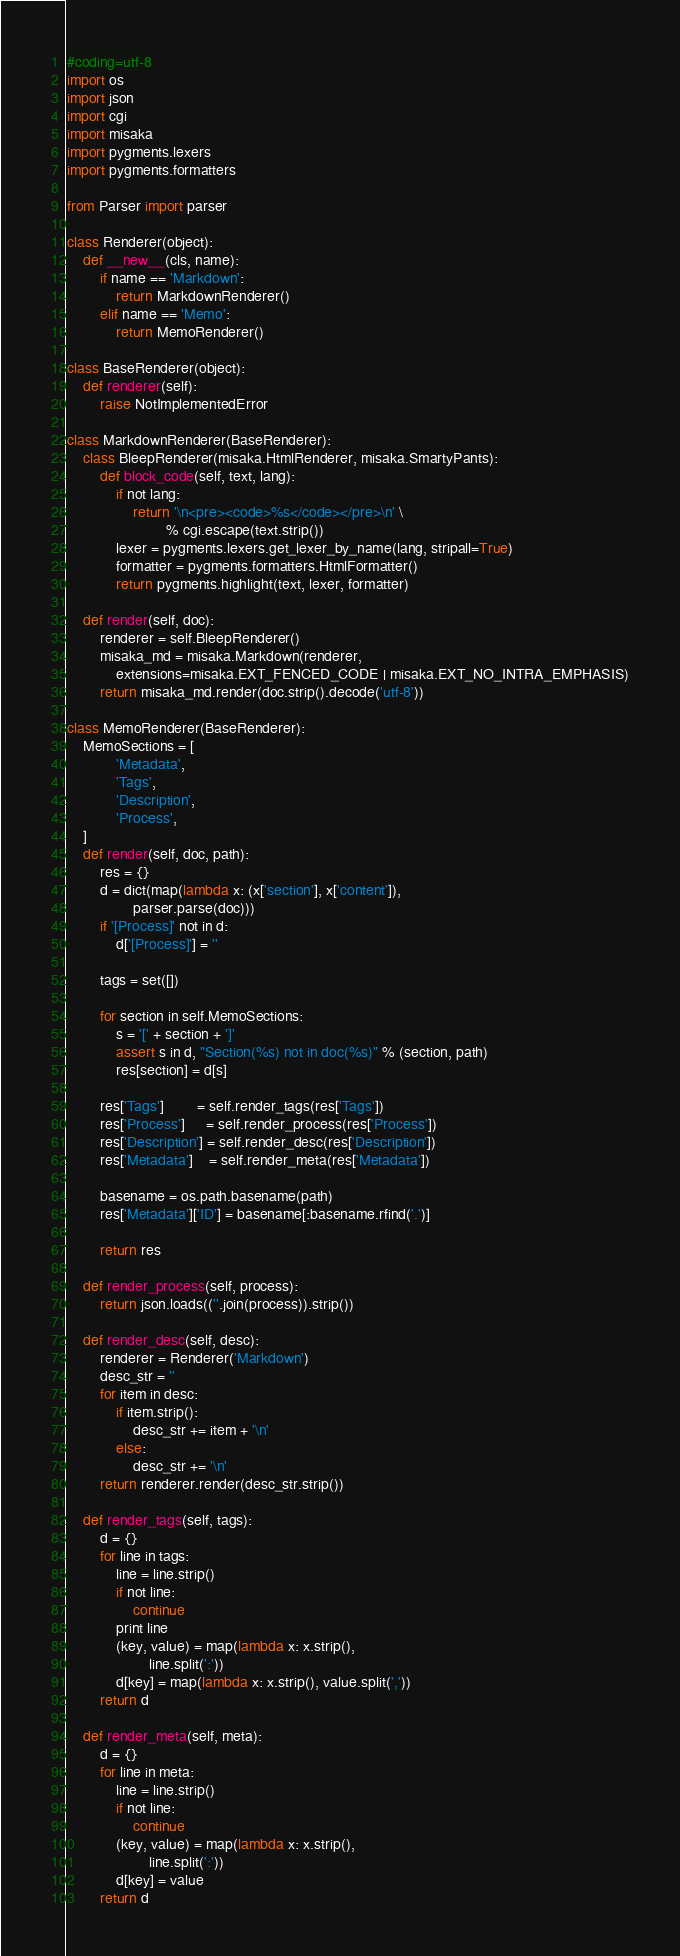<code> <loc_0><loc_0><loc_500><loc_500><_Python_>#coding=utf-8
import os
import json
import cgi
import misaka
import pygments.lexers
import pygments.formatters

from Parser import parser

class Renderer(object):
    def __new__(cls, name):
        if name == 'Markdown':
            return MarkdownRenderer()
        elif name == 'Memo':
            return MemoRenderer()

class BaseRenderer(object):
    def renderer(self):
        raise NotImplementedError

class MarkdownRenderer(BaseRenderer):
    class BleepRenderer(misaka.HtmlRenderer, misaka.SmartyPants):
        def block_code(self, text, lang):
            if not lang:
                return '\n<pre><code>%s</code></pre>\n' \
                        % cgi.escape(text.strip())
            lexer = pygments.lexers.get_lexer_by_name(lang, stripall=True)
            formatter = pygments.formatters.HtmlFormatter()
            return pygments.highlight(text, lexer, formatter)

    def render(self, doc):
        renderer = self.BleepRenderer()
        misaka_md = misaka.Markdown(renderer,
            extensions=misaka.EXT_FENCED_CODE | misaka.EXT_NO_INTRA_EMPHASIS)
        return misaka_md.render(doc.strip().decode('utf-8'))

class MemoRenderer(BaseRenderer):
    MemoSections = [
            'Metadata',
            'Tags',
            'Description',
            'Process',
    ]
    def render(self, doc, path):
        res = {}
        d = dict(map(lambda x: (x['section'], x['content']), 
                parser.parse(doc)))
        if '[Process]' not in d:
            d['[Process]'] = ''

        tags = set([])

        for section in self.MemoSections:
            s = '[' + section + ']'
            assert s in d, "Section(%s) not in doc(%s)" % (section, path)
            res[section] = d[s]

        res['Tags']        = self.render_tags(res['Tags'])
        res['Process']     = self.render_process(res['Process'])
        res['Description'] = self.render_desc(res['Description'])
        res['Metadata']    = self.render_meta(res['Metadata'])

        basename = os.path.basename(path)
        res['Metadata']['ID'] = basename[:basename.rfind('.')]

        return res

    def render_process(self, process):
        return json.loads((''.join(process)).strip())

    def render_desc(self, desc):
        renderer = Renderer('Markdown')
        desc_str = ''
        for item in desc:
            if item.strip():
                desc_str += item + '\n'
            else:
                desc_str += '\n'
        return renderer.render(desc_str.strip())

    def render_tags(self, tags):
        d = {}
        for line in tags:
            line = line.strip()
            if not line:
                continue
            print line
            (key, value) = map(lambda x: x.strip(),
                    line.split(':'))
            d[key] = map(lambda x: x.strip(), value.split(','))
        return d

    def render_meta(self, meta):
        d = {}
        for line in meta:
            line = line.strip()
            if not line:
                continue
            (key, value) = map(lambda x: x.strip(),
                    line.split(':'))
            d[key] = value
        return d

</code> 